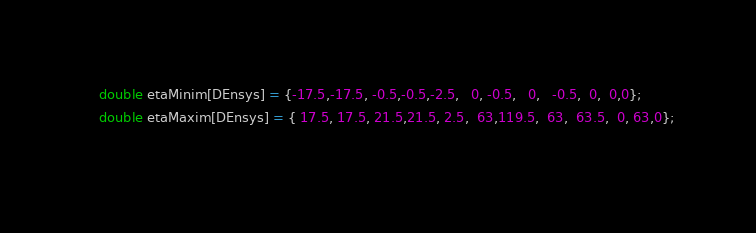Convert code to text. <code><loc_0><loc_0><loc_500><loc_500><_C++_>    double etaMinim[DEnsys] = {-17.5,-17.5, -0.5,-0.5,-2.5,   0, -0.5,   0,   -0.5,  0,  0,0};
    double etaMaxim[DEnsys] = { 17.5, 17.5, 21.5,21.5, 2.5,  63,119.5,  63,  63.5,  0, 63,0};
  </code> 